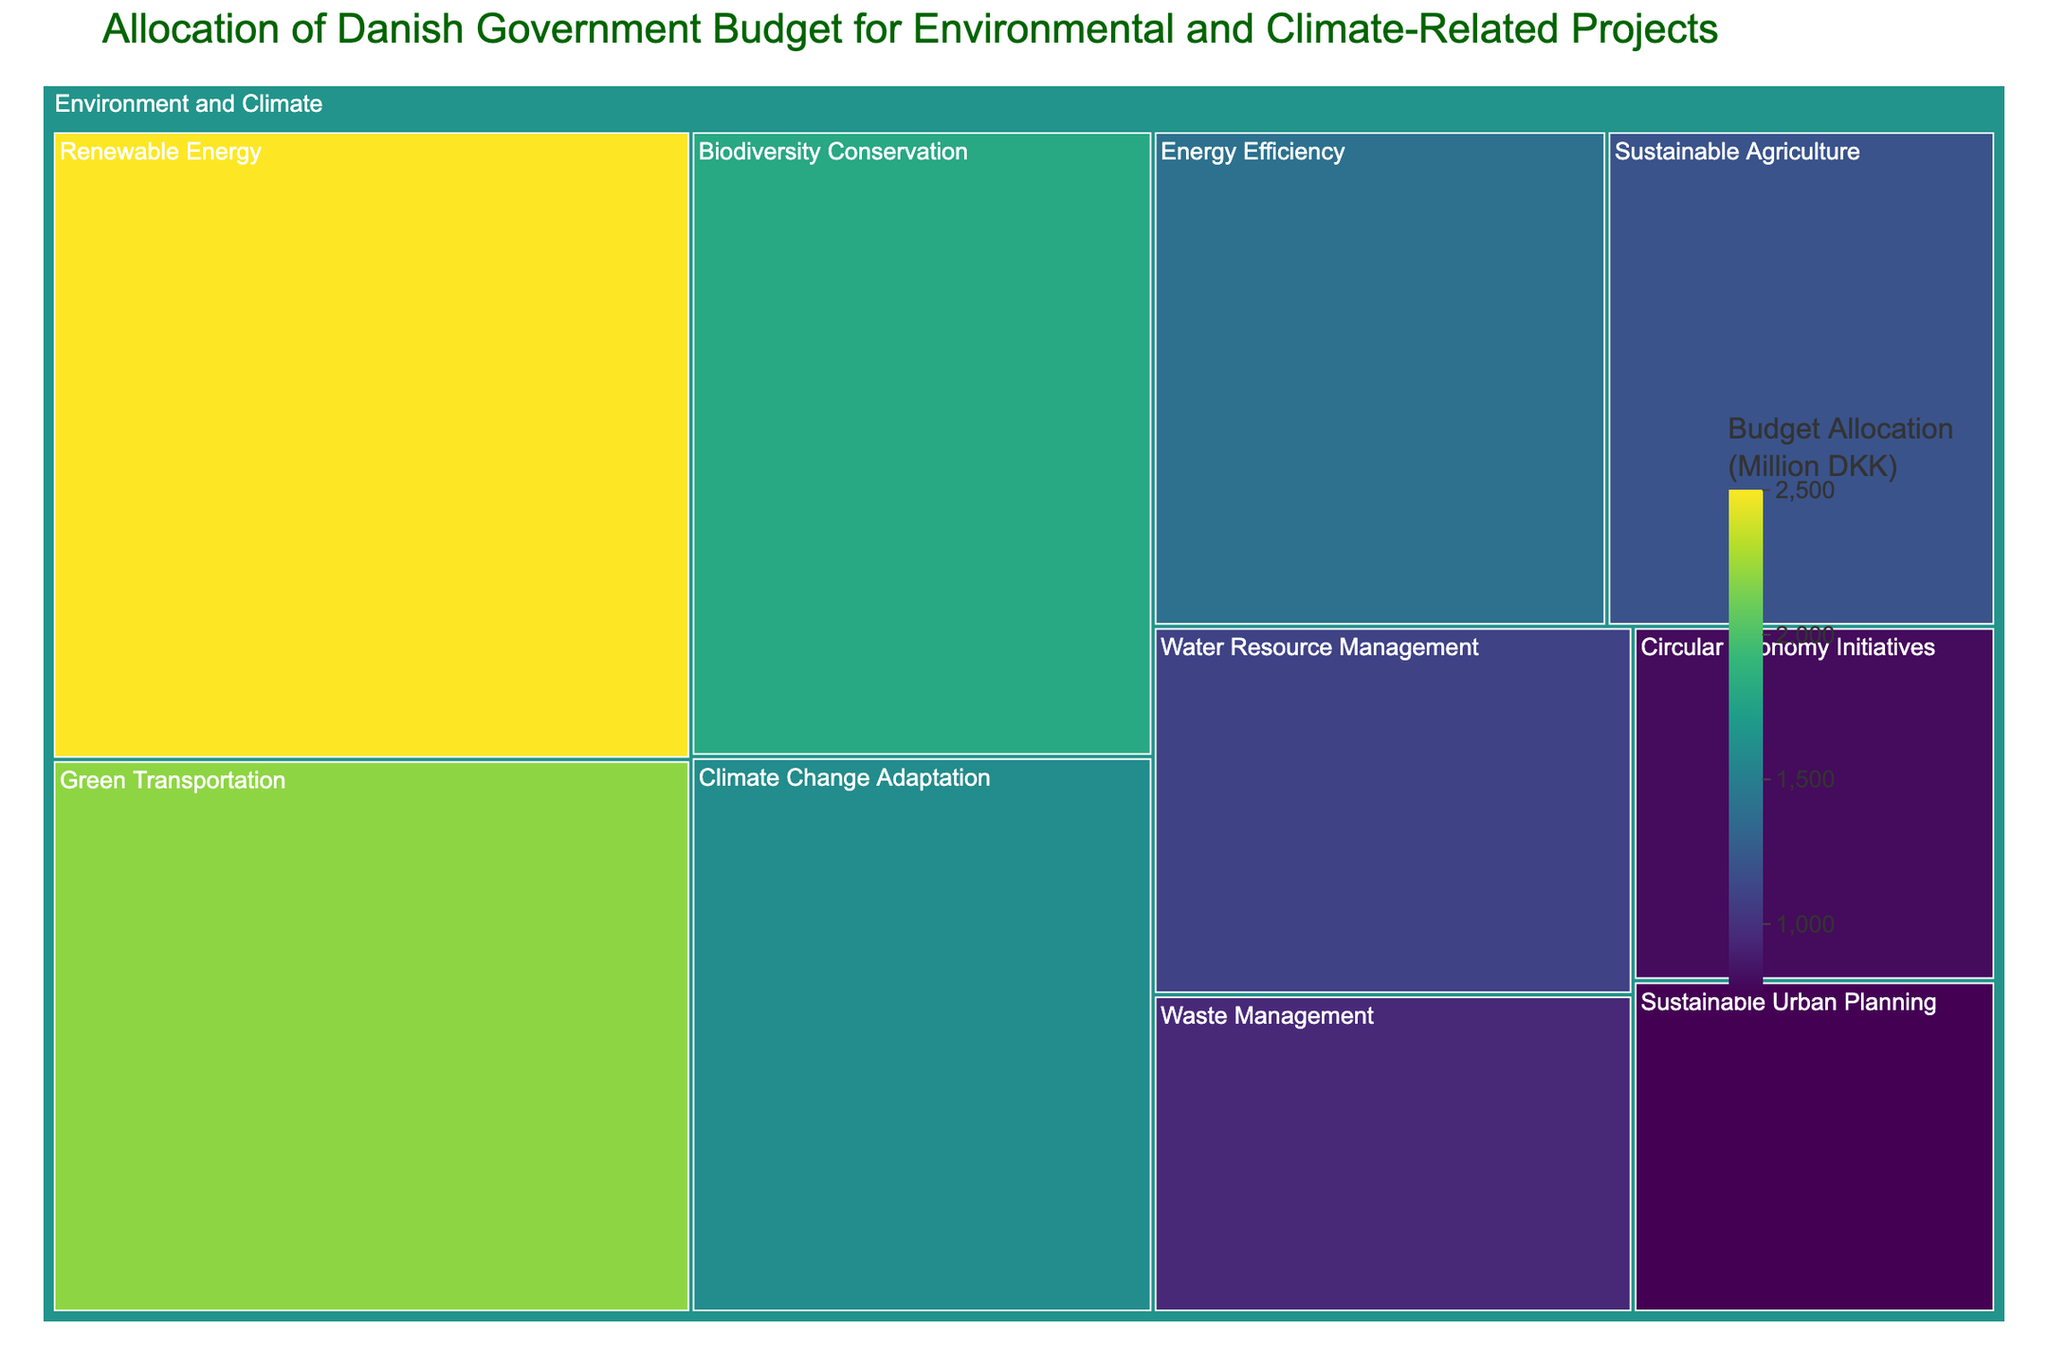What is the title of the treemap? The title is typically located at the top of the figure and is designed to inform the viewer of the subject of the visualization.
Answer: Allocation of Danish Government Budget for Environmental and Climate-Related Projects Which subsector has the largest budget allocation? You can determine this by visually inspecting the treemap and identifying the largest rectangle, as the area is proportional to the budget.
Answer: Renewable Energy How much budget is allocated for Green Transportation? Hover over the rectangle labeled "Green Transportation" to reveal the specific budget allocation displayed in the hover data.
Answer: 2200 Million DKK What's the total budget allocation for Biodiversity Conservation and Climate Change Adaptation combined? Locate the rectangles for both subsectors and add their budget allocations: 1800 + 1600 = 3400 Million DKK
Answer: 3400 Million DKK Which subsector receives less budget, Sustainable Urban Planning or Circular Economy Initiatives? Compare the areas of the rectangles or check the hover data for each subsector. Circular Economy Initiatives (800 Million DKK) is less than Sustainable Urban Planning (750 Million DKK).
Answer: Circular Economy Initiatives How many subsectors are included under Environment and Climate? Count the distinct rectangles (subsectors) under the "Environment and Climate" sector.
Answer: 10 What is the difference in budget allocation between the largest and smallest subsectors? Identify the largest and smallest subsectors (Renewable Energy and Sustainable Urban Planning) and calculate the difference: 2500 - 750 = 1750 Million DKK
Answer: 1750 Million DKK Is the budget for Waste Management greater than that for Energy Efficiency? Compare the areas or hover data of the respective rectangles: Waste Management (950 Million DKK) is less than Energy Efficiency (1400 Million DKK).
Answer: No What's the average budget allocation per subsector under the Environment and Climate sector? Sum all the budget allocations and divide by the number of subsectors (10): (2500 + 1800 + 1200 + 950 + 1600 + 2200 + 1400 + 800 + 1100 + 750) / 10 = 1430 Million DKK
Answer: 1430 Million DKK Which subsector has a budget closest to 1000 Million DKK? Locate and compare the budget values of each subsector to find the one nearest to 1000 Million DKK.
Answer: Water Resource Management (1100 Million DKK) 